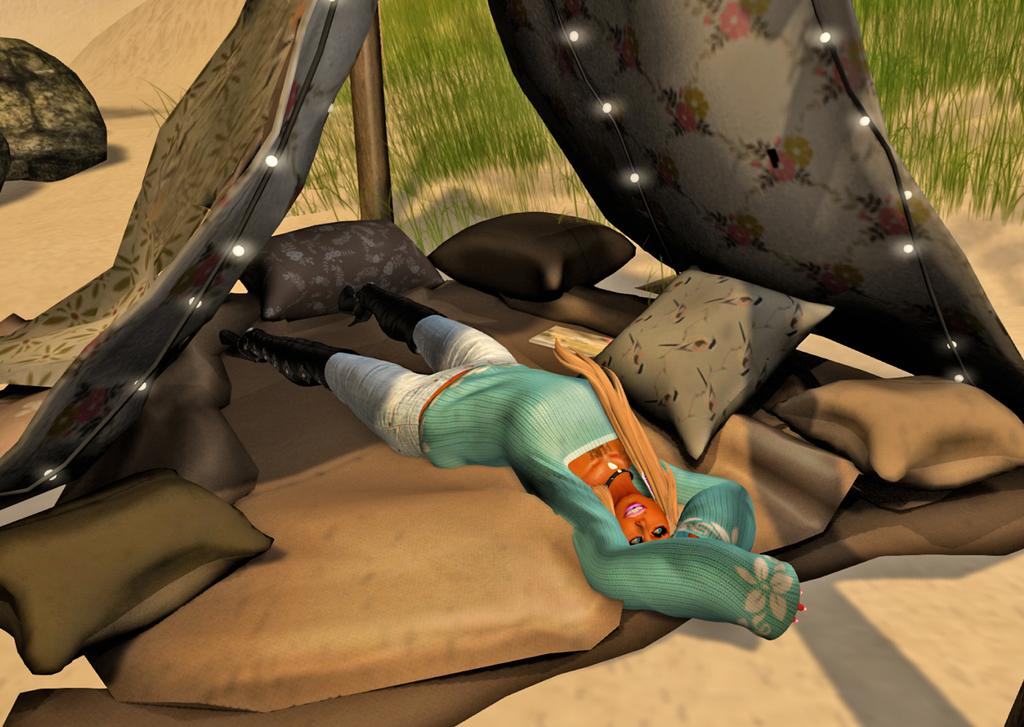What type of image is being described? The image is animated. What is the woman doing in the image? The woman is lying under a tent in the image. What type of seating is present in the image? There are pillows and cushions in the image. What type of lighting is present in the image? There are ceiling lights in the image. What type of natural elements are present in the image? There are stones and grass in the image. What type of structure is present in the image? There is a pole in the image. How many attempts does the woman make to open the bottle in the image? There is no bottle present in the image, so the question cannot be answered. 